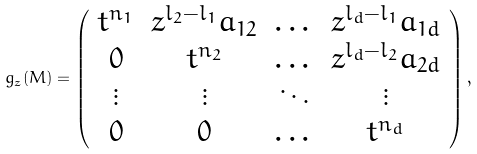Convert formula to latex. <formula><loc_0><loc_0><loc_500><loc_500>g _ { z } ( M ) = \left ( \begin{array} { c c c c } t ^ { n _ { 1 } } & z ^ { l _ { 2 } - l _ { 1 } } a _ { 1 2 } & \dots & z ^ { l _ { d } - l _ { 1 } } a _ { 1 d } \\ 0 & t ^ { n _ { 2 } } & \dots & z ^ { l _ { d } - l _ { 2 } } a _ { 2 d } \\ \vdots & \vdots & \ddots & \vdots \\ 0 & 0 & \dots & t ^ { n _ { d } } \end{array} \right ) ,</formula> 